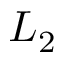<formula> <loc_0><loc_0><loc_500><loc_500>L _ { 2 }</formula> 